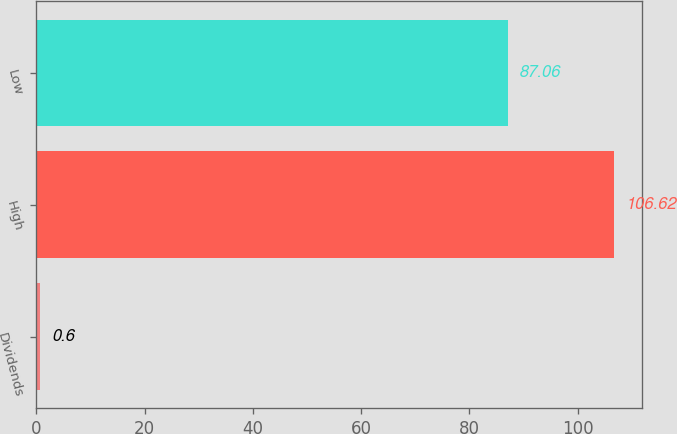Convert chart. <chart><loc_0><loc_0><loc_500><loc_500><bar_chart><fcel>Dividends<fcel>High<fcel>Low<nl><fcel>0.6<fcel>106.62<fcel>87.06<nl></chart> 